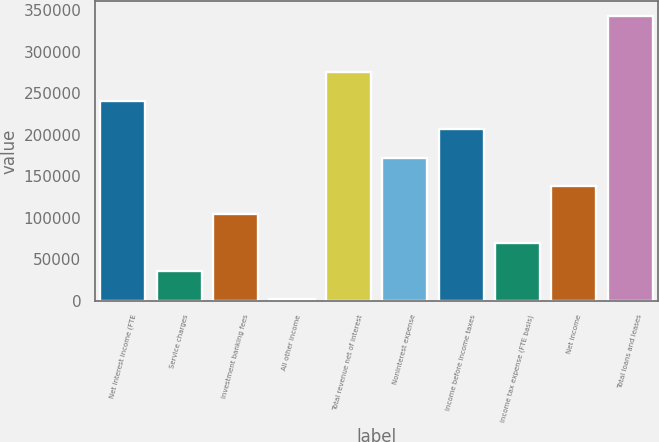<chart> <loc_0><loc_0><loc_500><loc_500><bar_chart><fcel>Net interest income (FTE<fcel>Service charges<fcel>Investment banking fees<fcel>All other income<fcel>Total revenue net of interest<fcel>Noninterest expense<fcel>Income before income taxes<fcel>Income tax expense (FTE basis)<fcel>Net income<fcel>Total loans and leases<nl><fcel>240888<fcel>35736.9<fcel>104121<fcel>1545<fcel>275080<fcel>172504<fcel>206696<fcel>69928.8<fcel>138313<fcel>343464<nl></chart> 